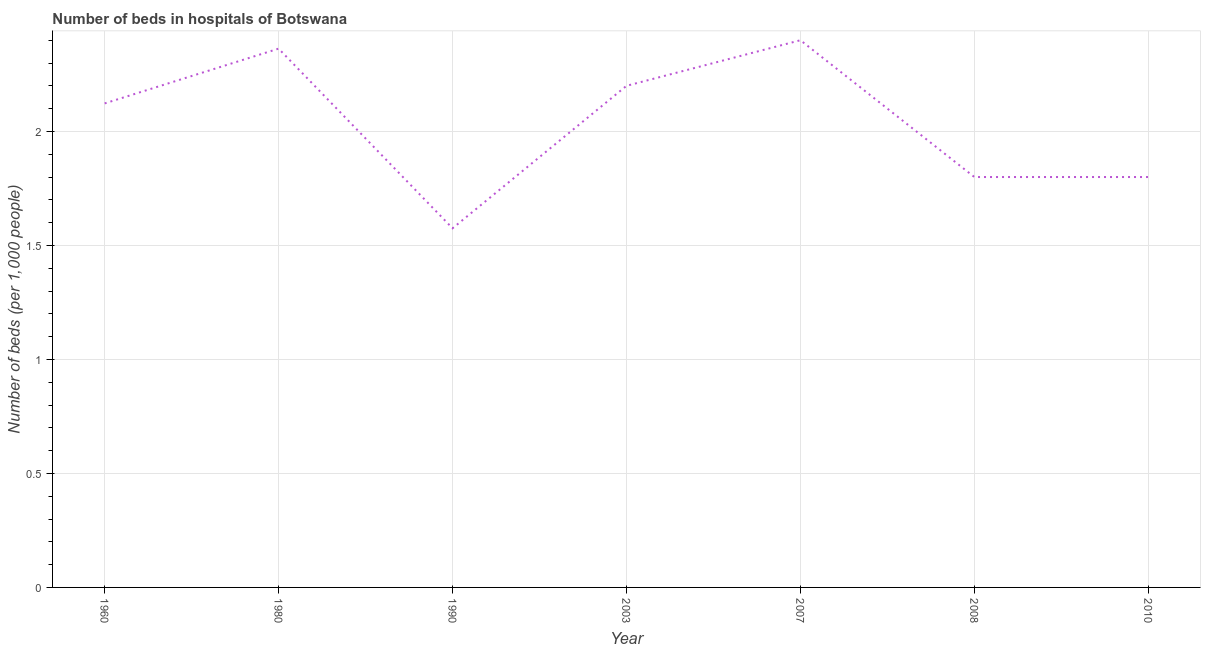What is the number of hospital beds in 1980?
Offer a very short reply. 2.36. Across all years, what is the minimum number of hospital beds?
Keep it short and to the point. 1.58. In which year was the number of hospital beds minimum?
Your response must be concise. 1990. What is the sum of the number of hospital beds?
Keep it short and to the point. 14.26. What is the difference between the number of hospital beds in 1990 and 2010?
Your answer should be compact. -0.22. What is the average number of hospital beds per year?
Ensure brevity in your answer.  2.04. What is the median number of hospital beds?
Ensure brevity in your answer.  2.12. Do a majority of the years between 1960 and 2007 (inclusive) have number of hospital beds greater than 1.6 %?
Offer a very short reply. Yes. What is the ratio of the number of hospital beds in 1980 to that in 2010?
Your answer should be compact. 1.31. What is the difference between the highest and the second highest number of hospital beds?
Offer a terse response. 0.04. Is the sum of the number of hospital beds in 1960 and 2010 greater than the maximum number of hospital beds across all years?
Provide a short and direct response. Yes. What is the difference between the highest and the lowest number of hospital beds?
Your answer should be very brief. 0.82. In how many years, is the number of hospital beds greater than the average number of hospital beds taken over all years?
Your answer should be very brief. 4. How many lines are there?
Provide a short and direct response. 1. How many years are there in the graph?
Keep it short and to the point. 7. Are the values on the major ticks of Y-axis written in scientific E-notation?
Your answer should be very brief. No. Does the graph contain any zero values?
Provide a short and direct response. No. Does the graph contain grids?
Ensure brevity in your answer.  Yes. What is the title of the graph?
Offer a terse response. Number of beds in hospitals of Botswana. What is the label or title of the X-axis?
Your response must be concise. Year. What is the label or title of the Y-axis?
Give a very brief answer. Number of beds (per 1,0 people). What is the Number of beds (per 1,000 people) in 1960?
Provide a short and direct response. 2.12. What is the Number of beds (per 1,000 people) of 1980?
Provide a succinct answer. 2.36. What is the Number of beds (per 1,000 people) in 1990?
Provide a short and direct response. 1.58. What is the Number of beds (per 1,000 people) of 2003?
Give a very brief answer. 2.2. What is the Number of beds (per 1,000 people) of 2007?
Make the answer very short. 2.4. What is the Number of beds (per 1,000 people) in 2010?
Ensure brevity in your answer.  1.8. What is the difference between the Number of beds (per 1,000 people) in 1960 and 1980?
Offer a very short reply. -0.24. What is the difference between the Number of beds (per 1,000 people) in 1960 and 1990?
Keep it short and to the point. 0.55. What is the difference between the Number of beds (per 1,000 people) in 1960 and 2003?
Your response must be concise. -0.08. What is the difference between the Number of beds (per 1,000 people) in 1960 and 2007?
Give a very brief answer. -0.28. What is the difference between the Number of beds (per 1,000 people) in 1960 and 2008?
Your answer should be very brief. 0.32. What is the difference between the Number of beds (per 1,000 people) in 1960 and 2010?
Provide a succinct answer. 0.32. What is the difference between the Number of beds (per 1,000 people) in 1980 and 1990?
Make the answer very short. 0.79. What is the difference between the Number of beds (per 1,000 people) in 1980 and 2003?
Make the answer very short. 0.16. What is the difference between the Number of beds (per 1,000 people) in 1980 and 2007?
Make the answer very short. -0.04. What is the difference between the Number of beds (per 1,000 people) in 1980 and 2008?
Provide a succinct answer. 0.56. What is the difference between the Number of beds (per 1,000 people) in 1980 and 2010?
Keep it short and to the point. 0.56. What is the difference between the Number of beds (per 1,000 people) in 1990 and 2003?
Provide a succinct answer. -0.62. What is the difference between the Number of beds (per 1,000 people) in 1990 and 2007?
Give a very brief answer. -0.82. What is the difference between the Number of beds (per 1,000 people) in 1990 and 2008?
Provide a short and direct response. -0.22. What is the difference between the Number of beds (per 1,000 people) in 1990 and 2010?
Your answer should be compact. -0.22. What is the difference between the Number of beds (per 1,000 people) in 2003 and 2007?
Give a very brief answer. -0.2. What is the difference between the Number of beds (per 1,000 people) in 2007 and 2008?
Ensure brevity in your answer.  0.6. What is the difference between the Number of beds (per 1,000 people) in 2007 and 2010?
Provide a succinct answer. 0.6. What is the ratio of the Number of beds (per 1,000 people) in 1960 to that in 1980?
Offer a terse response. 0.9. What is the ratio of the Number of beds (per 1,000 people) in 1960 to that in 1990?
Your response must be concise. 1.35. What is the ratio of the Number of beds (per 1,000 people) in 1960 to that in 2007?
Offer a terse response. 0.89. What is the ratio of the Number of beds (per 1,000 people) in 1960 to that in 2008?
Keep it short and to the point. 1.18. What is the ratio of the Number of beds (per 1,000 people) in 1960 to that in 2010?
Your answer should be very brief. 1.18. What is the ratio of the Number of beds (per 1,000 people) in 1980 to that in 1990?
Provide a succinct answer. 1.5. What is the ratio of the Number of beds (per 1,000 people) in 1980 to that in 2003?
Your answer should be compact. 1.07. What is the ratio of the Number of beds (per 1,000 people) in 1980 to that in 2007?
Provide a succinct answer. 0.98. What is the ratio of the Number of beds (per 1,000 people) in 1980 to that in 2008?
Provide a succinct answer. 1.31. What is the ratio of the Number of beds (per 1,000 people) in 1980 to that in 2010?
Keep it short and to the point. 1.31. What is the ratio of the Number of beds (per 1,000 people) in 1990 to that in 2003?
Offer a terse response. 0.72. What is the ratio of the Number of beds (per 1,000 people) in 1990 to that in 2007?
Your answer should be compact. 0.66. What is the ratio of the Number of beds (per 1,000 people) in 1990 to that in 2010?
Keep it short and to the point. 0.88. What is the ratio of the Number of beds (per 1,000 people) in 2003 to that in 2007?
Keep it short and to the point. 0.92. What is the ratio of the Number of beds (per 1,000 people) in 2003 to that in 2008?
Your answer should be compact. 1.22. What is the ratio of the Number of beds (per 1,000 people) in 2003 to that in 2010?
Ensure brevity in your answer.  1.22. What is the ratio of the Number of beds (per 1,000 people) in 2007 to that in 2008?
Provide a short and direct response. 1.33. What is the ratio of the Number of beds (per 1,000 people) in 2007 to that in 2010?
Give a very brief answer. 1.33. 